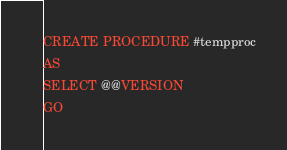Convert code to text. <code><loc_0><loc_0><loc_500><loc_500><_SQL_>CREATE PROCEDURE #tempproc
AS
SELECT @@VERSION
GO</code> 